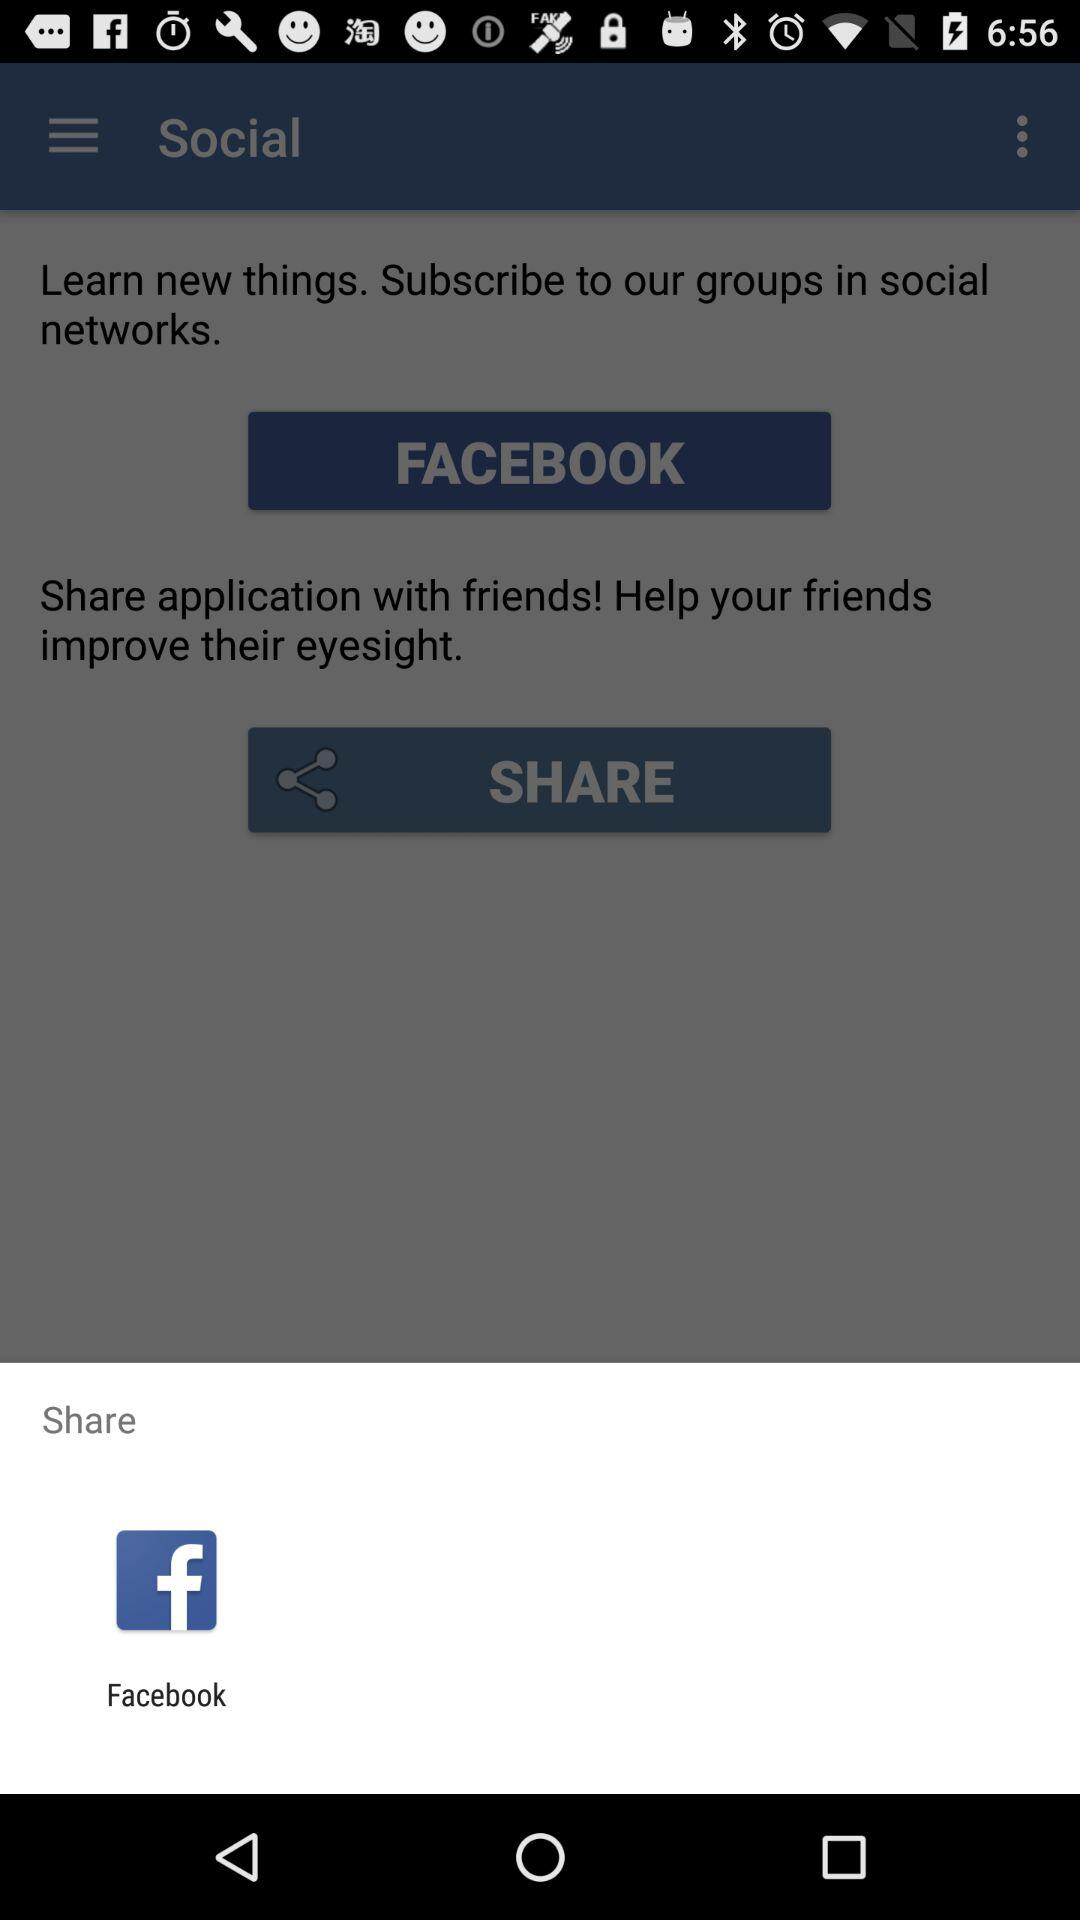What is the name of the application?
When the provided information is insufficient, respond with <no answer>. <no answer> 